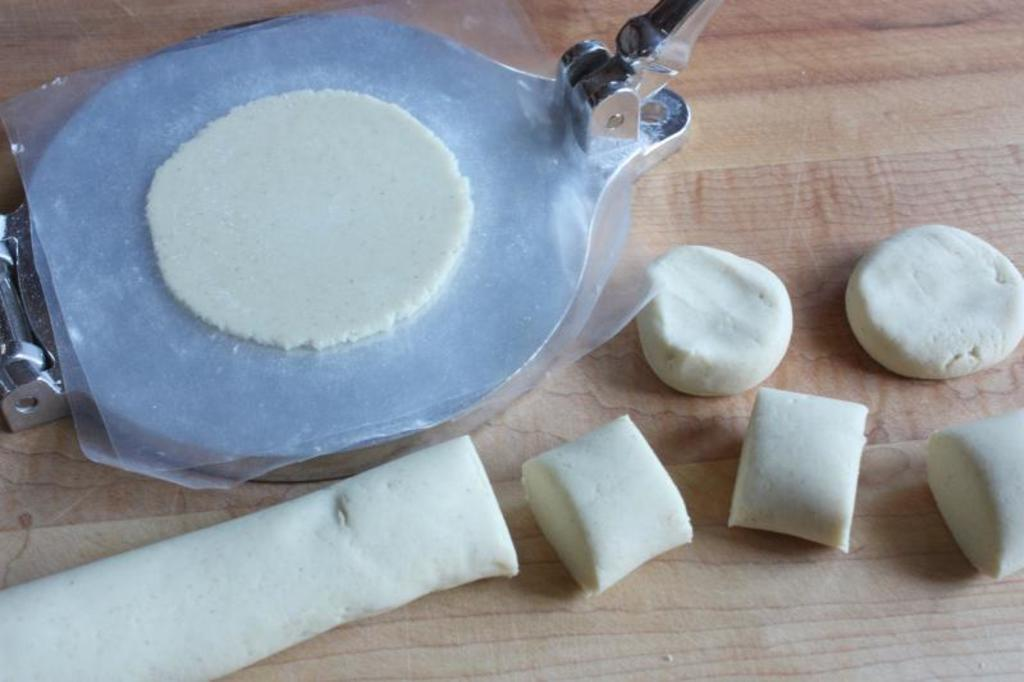What is the main object in the image? There is a machine in the image. What is inside the machine? There is dough inside the machine. Can you describe the dough outside the machine? There is dough at the bottom of the image. What else is present in the image besides the machine and dough? There is a blanket in the image. What type of cord is connected to the top of the machine in the image? There is no cord connected to the top of the machine in the image. 